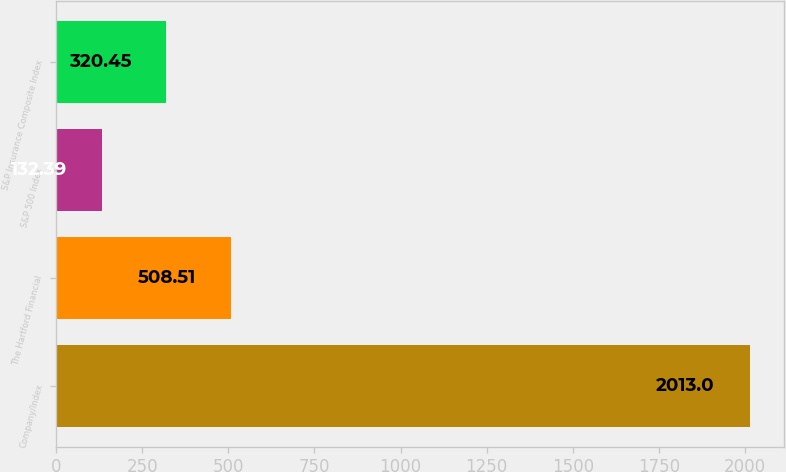<chart> <loc_0><loc_0><loc_500><loc_500><bar_chart><fcel>Company/Index<fcel>The Hartford Financial<fcel>S&P 500 Index<fcel>S&P Insurance Composite Index<nl><fcel>2013<fcel>508.51<fcel>132.39<fcel>320.45<nl></chart> 